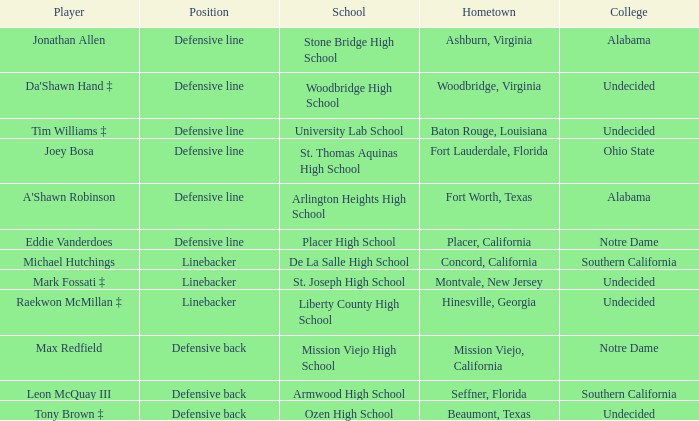What role did max redfield perform? Defensive back. Could you parse the entire table? {'header': ['Player', 'Position', 'School', 'Hometown', 'College'], 'rows': [['Jonathan Allen', 'Defensive line', 'Stone Bridge High School', 'Ashburn, Virginia', 'Alabama'], ["Da'Shawn Hand ‡", 'Defensive line', 'Woodbridge High School', 'Woodbridge, Virginia', 'Undecided'], ['Tim Williams ‡', 'Defensive line', 'University Lab School', 'Baton Rouge, Louisiana', 'Undecided'], ['Joey Bosa', 'Defensive line', 'St. Thomas Aquinas High School', 'Fort Lauderdale, Florida', 'Ohio State'], ["A'Shawn Robinson", 'Defensive line', 'Arlington Heights High School', 'Fort Worth, Texas', 'Alabama'], ['Eddie Vanderdoes', 'Defensive line', 'Placer High School', 'Placer, California', 'Notre Dame'], ['Michael Hutchings', 'Linebacker', 'De La Salle High School', 'Concord, California', 'Southern California'], ['Mark Fossati ‡', 'Linebacker', 'St. Joseph High School', 'Montvale, New Jersey', 'Undecided'], ['Raekwon McMillan ‡', 'Linebacker', 'Liberty County High School', 'Hinesville, Georgia', 'Undecided'], ['Max Redfield', 'Defensive back', 'Mission Viejo High School', 'Mission Viejo, California', 'Notre Dame'], ['Leon McQuay III', 'Defensive back', 'Armwood High School', 'Seffner, Florida', 'Southern California'], ['Tony Brown ‡', 'Defensive back', 'Ozen High School', 'Beaumont, Texas', 'Undecided']]} 